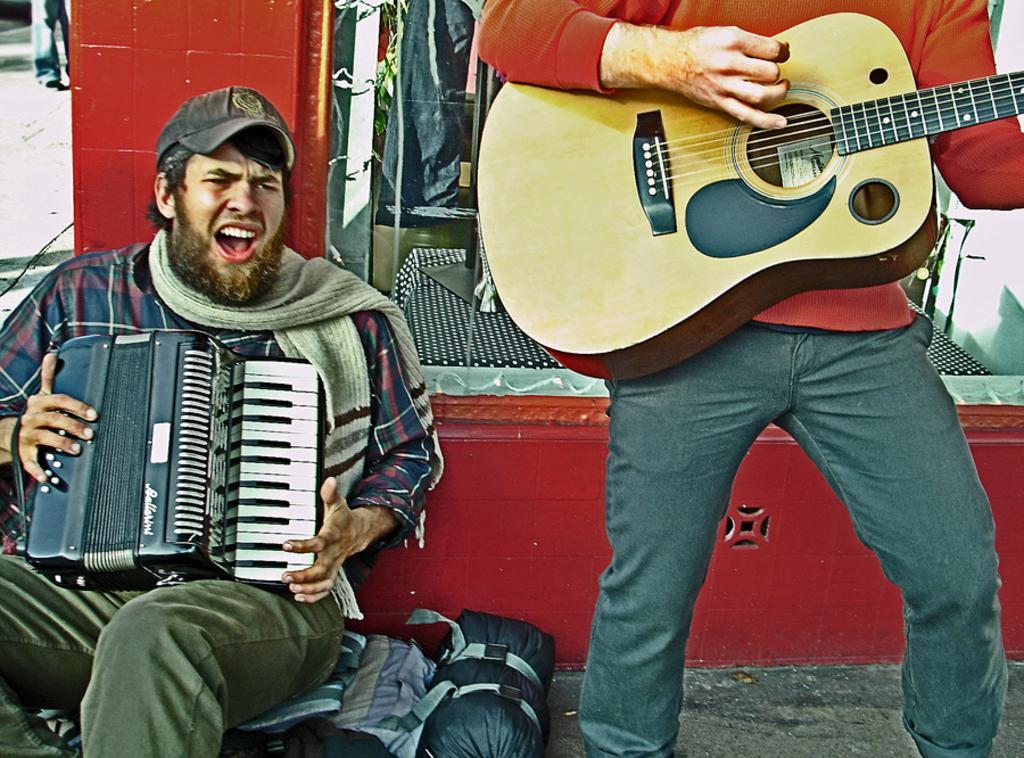How would you summarize this image in a sentence or two? This picture is of outside. On the right there is a Man standing and playing Guitar. On the left there is a Man sitting and playing a musical instrument and seems to be singing. In the background we can see the ground and a Van 